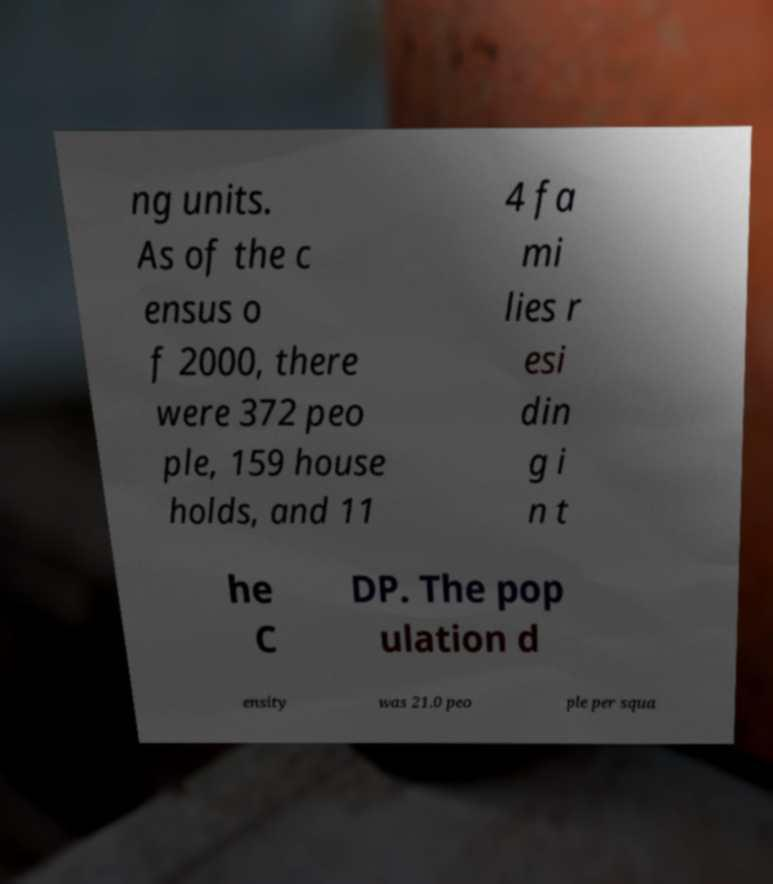I need the written content from this picture converted into text. Can you do that? ng units. As of the c ensus o f 2000, there were 372 peo ple, 159 house holds, and 11 4 fa mi lies r esi din g i n t he C DP. The pop ulation d ensity was 21.0 peo ple per squa 